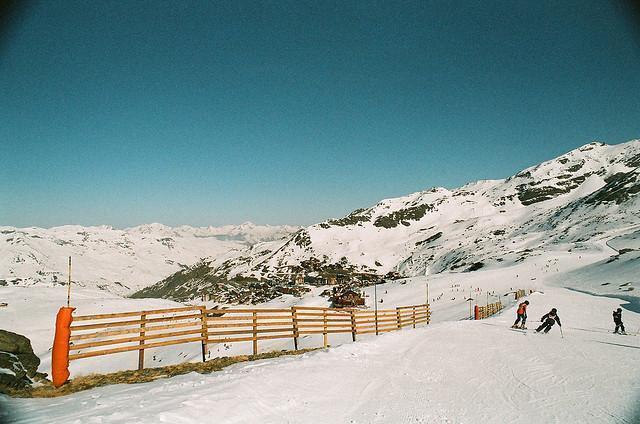What use is the fencing shown here?
Indicate the correct response by choosing from the four available options to answer the question.
Options: Boundary guideline, decorative, livestock containment, crop protection. Boundary guideline. 